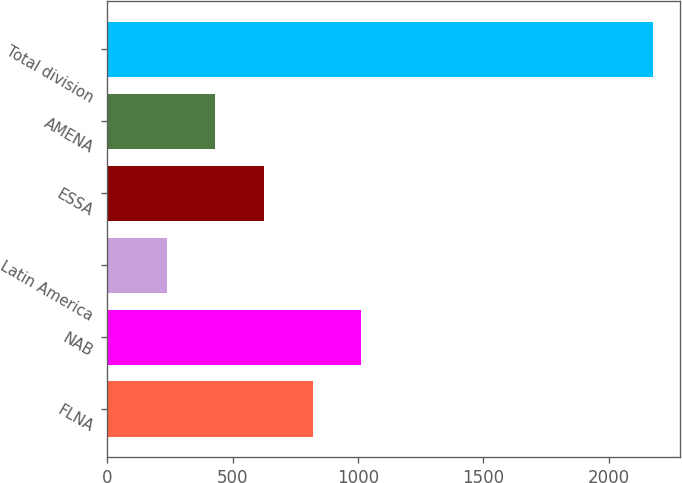<chart> <loc_0><loc_0><loc_500><loc_500><bar_chart><fcel>FLNA<fcel>NAB<fcel>Latin America<fcel>ESSA<fcel>AMENA<fcel>Total division<nl><fcel>819.1<fcel>1012.8<fcel>238<fcel>625.4<fcel>431.7<fcel>2175<nl></chart> 